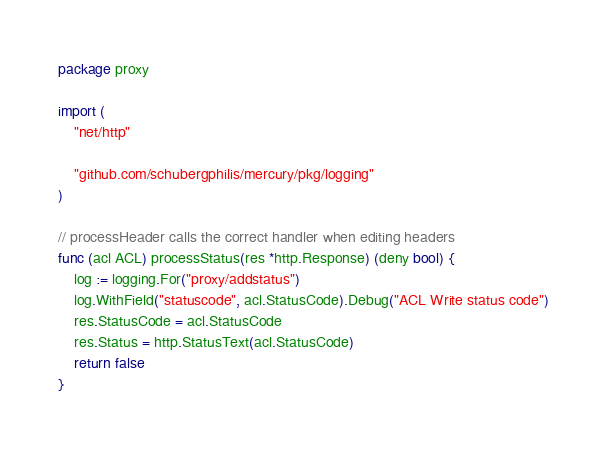<code> <loc_0><loc_0><loc_500><loc_500><_Go_>package proxy

import (
	"net/http"

	"github.com/schubergphilis/mercury/pkg/logging"
)

// processHeader calls the correct handler when editing headers
func (acl ACL) processStatus(res *http.Response) (deny bool) {
	log := logging.For("proxy/addstatus")
	log.WithField("statuscode", acl.StatusCode).Debug("ACL Write status code")
	res.StatusCode = acl.StatusCode
	res.Status = http.StatusText(acl.StatusCode)
	return false
}
</code> 